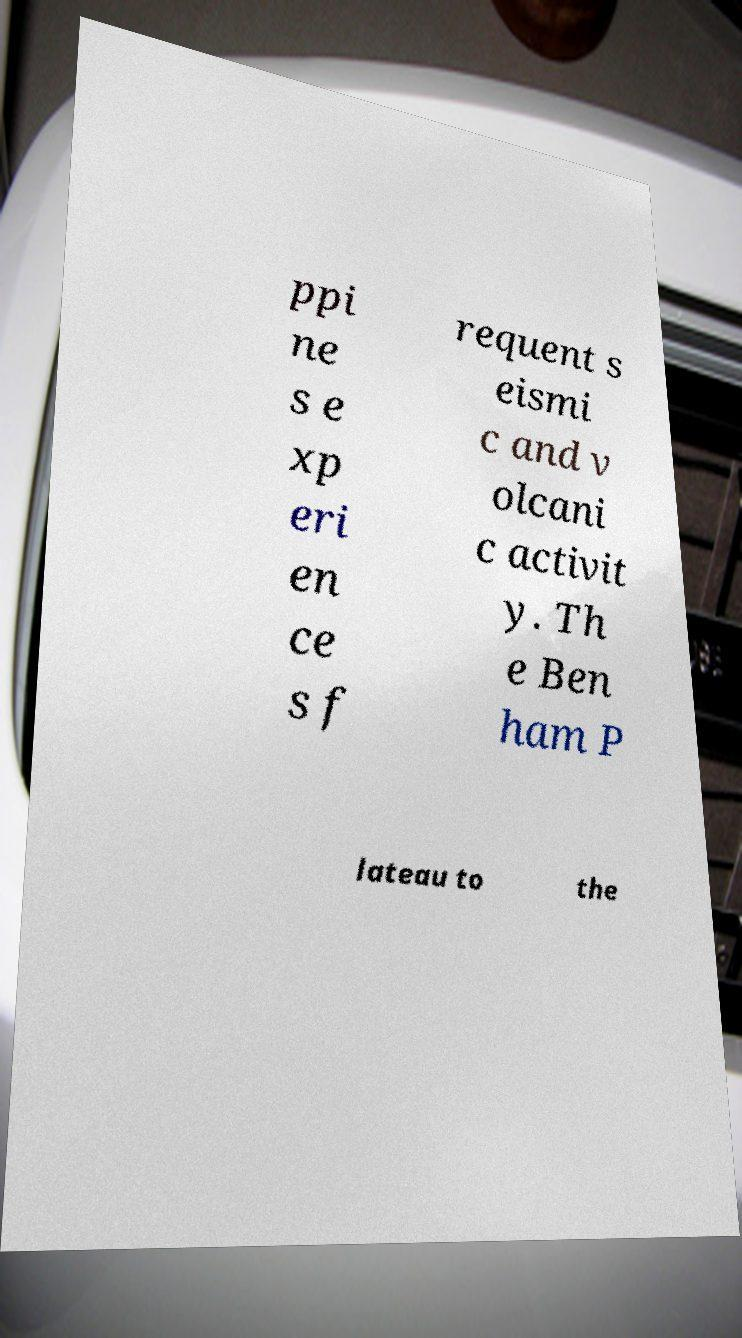Please identify and transcribe the text found in this image. ppi ne s e xp eri en ce s f requent s eismi c and v olcani c activit y. Th e Ben ham P lateau to the 